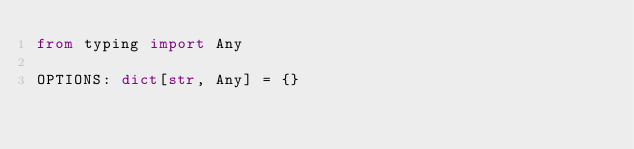Convert code to text. <code><loc_0><loc_0><loc_500><loc_500><_Python_>from typing import Any

OPTIONS: dict[str, Any] = {}
</code> 